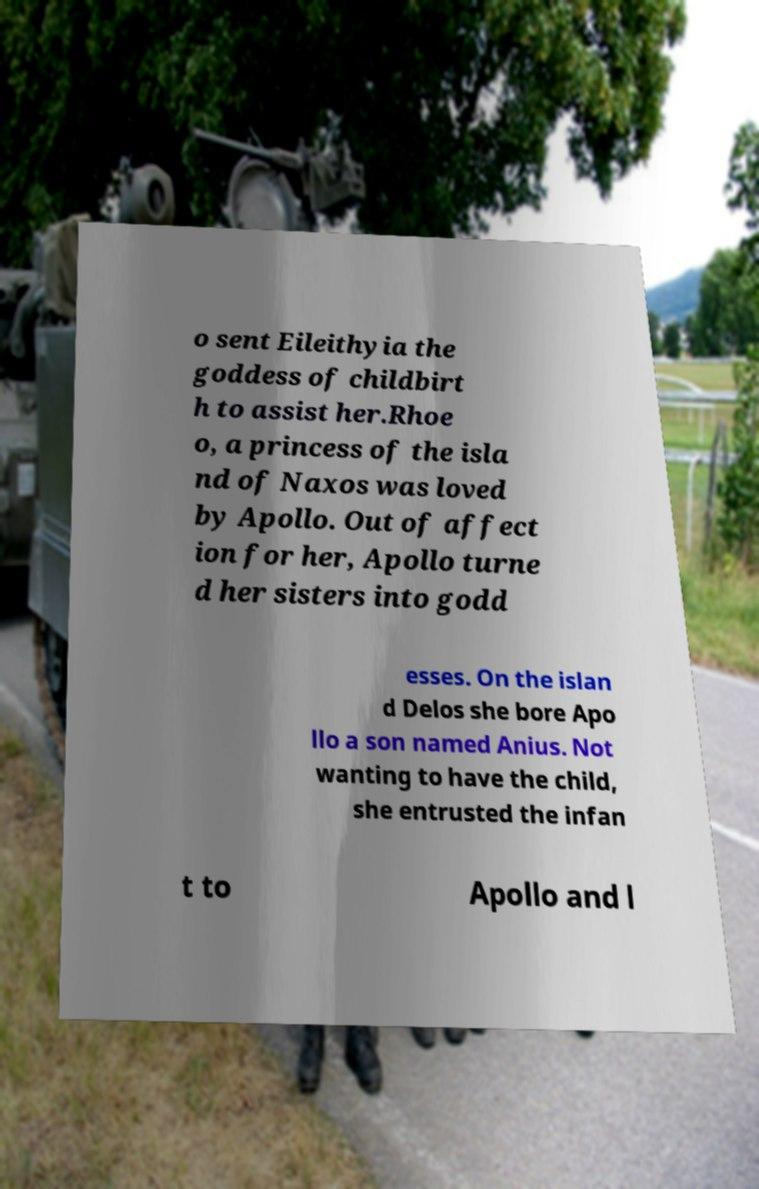Could you extract and type out the text from this image? o sent Eileithyia the goddess of childbirt h to assist her.Rhoe o, a princess of the isla nd of Naxos was loved by Apollo. Out of affect ion for her, Apollo turne d her sisters into godd esses. On the islan d Delos she bore Apo llo a son named Anius. Not wanting to have the child, she entrusted the infan t to Apollo and l 